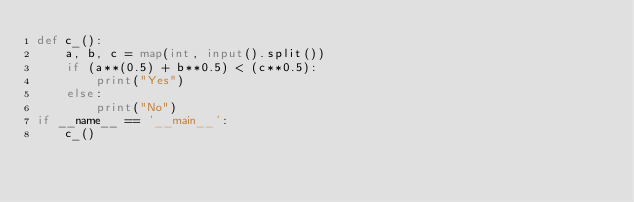Convert code to text. <code><loc_0><loc_0><loc_500><loc_500><_Python_>def c_():
    a, b, c = map(int, input().split())
    if (a**(0.5) + b**0.5) < (c**0.5):
        print("Yes")
    else:
        print("No")
if __name__ == '__main__':
    c_()
</code> 